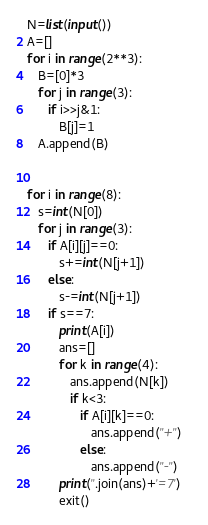<code> <loc_0><loc_0><loc_500><loc_500><_Python_>N=list(input())
A=[]
for i in range(2**3):
   B=[0]*3
   for j in range(3):
      if i>>j&1:
         B[j]=1
   A.append(B)


for i in range(8):
   s=int(N[0])
   for j in range(3):
      if A[i][j]==0:
         s+=int(N[j+1])
      else:
         s-=int(N[j+1])
      if s==7:
         print(A[i])
         ans=[]
         for k in range(4):
            ans.append(N[k])
            if k<3:
               if A[i][k]==0:
                  ans.append("+")
               else:
                  ans.append("-")   
         print(''.join(ans)+'=7')   
         exit()</code> 